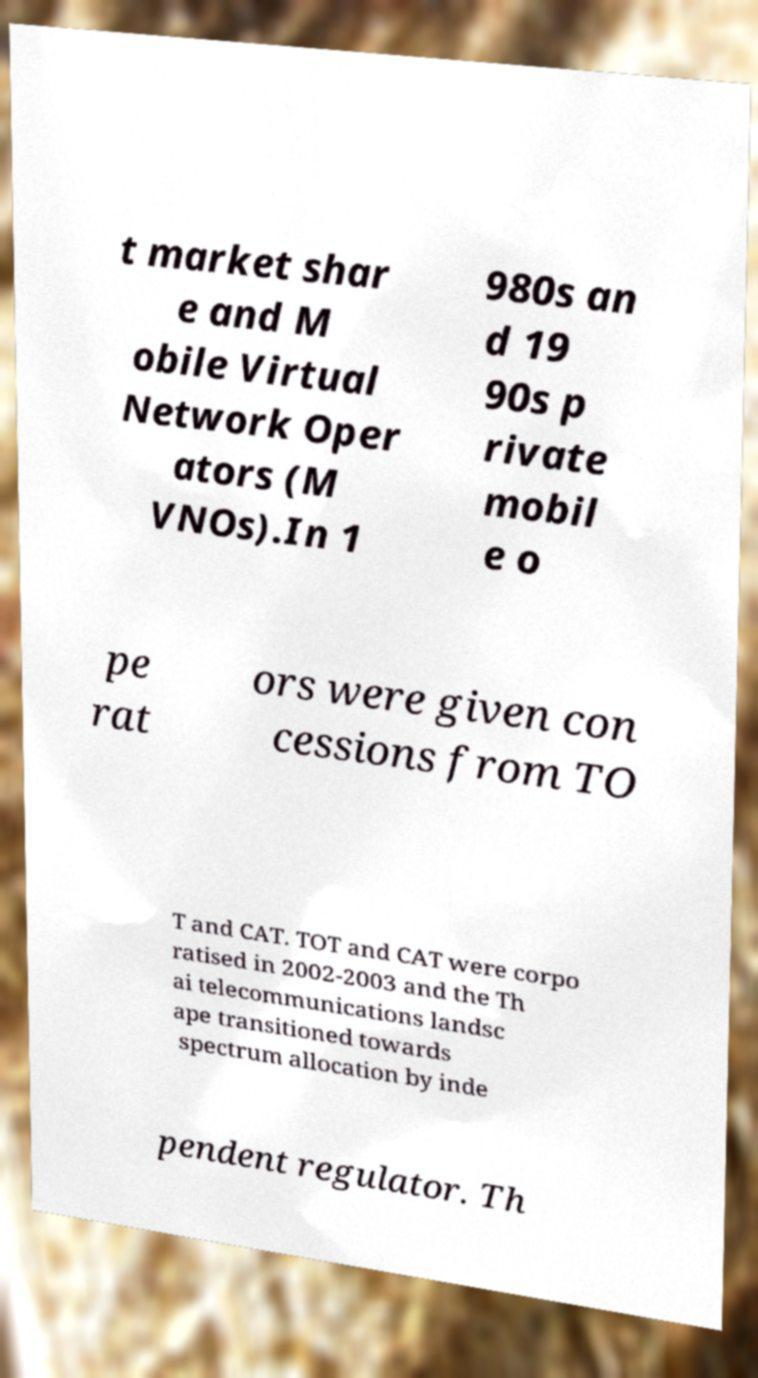Could you assist in decoding the text presented in this image and type it out clearly? t market shar e and M obile Virtual Network Oper ators (M VNOs).In 1 980s an d 19 90s p rivate mobil e o pe rat ors were given con cessions from TO T and CAT. TOT and CAT were corpo ratised in 2002-2003 and the Th ai telecommunications landsc ape transitioned towards spectrum allocation by inde pendent regulator. Th 